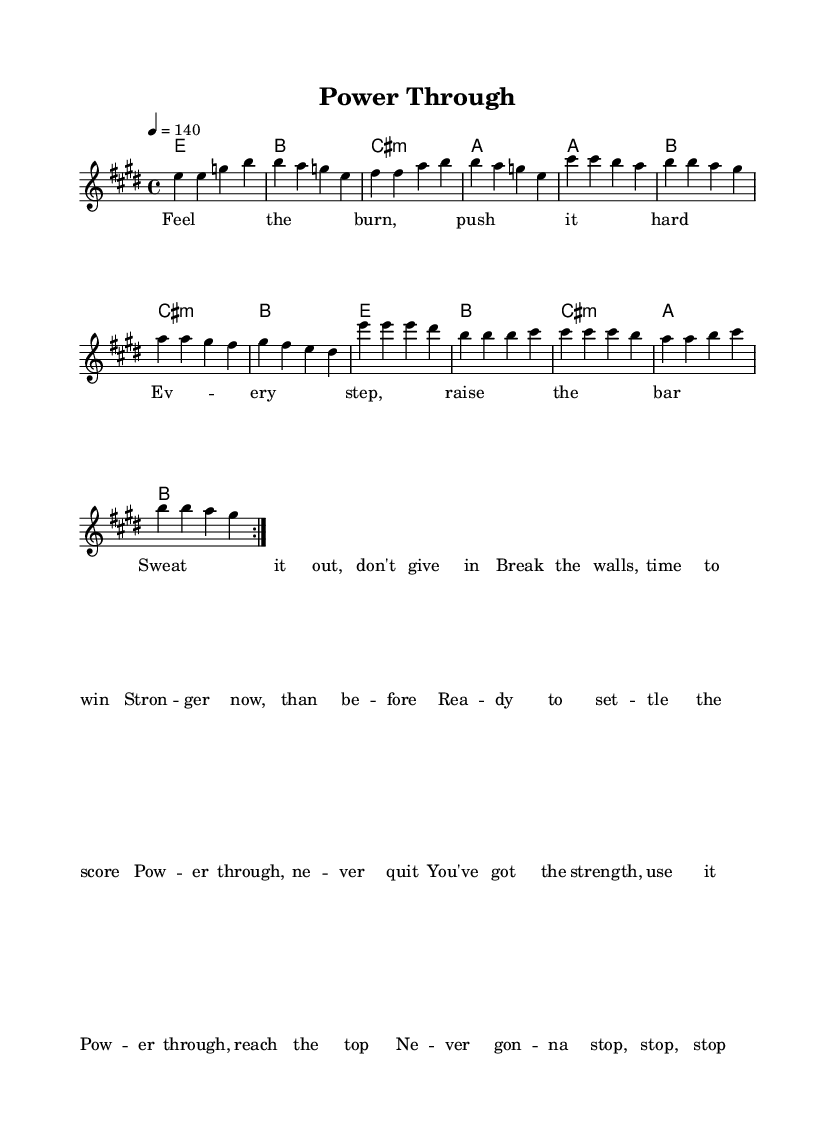What is the key signature of this music? The key signature is E major, which has four sharps (F#, C#, G#, D#). This can be identified at the beginning of the staff where the sharps are indicated.
Answer: E major What is the time signature of this piece? The time signature shown at the beginning is 4/4, indicated by the two numbers (4 above 4). This means there are four beats per measure and the quarter note gets one beat.
Answer: 4/4 What is the tempo marking for this song? The tempo marking is 140 beats per minute, indicated by "4 = 140" at the beginning of the score. This means that a quarter note is played at a speed of 140 beats per minute.
Answer: 140 How many measures are in one volta repeat? Each volta repeat contains eight measures, as seen in the repeated section that contains a total of eight distinct measures. This section is repeated twice in the score.
Answer: 8 What is the primary mood conveyed by the lyrics of this piece? The lyrics convey a motivational and empowering mood, focusing on themes of strength, determination, and overcoming challenges. This can be inferred from the choice of words like "power," "strength," and "never quit."
Answer: Motivational What type of rock genre does this piece imply based on its lyrical content? Based on the energetic and encouraging lyrics, combined with the usual guitar-driven sound suggested in the harmony, this piece implies an upbeat modern rock anthem. This genre typically focuses on themes of motivation and perseverance.
Answer: Modern rock anthem 